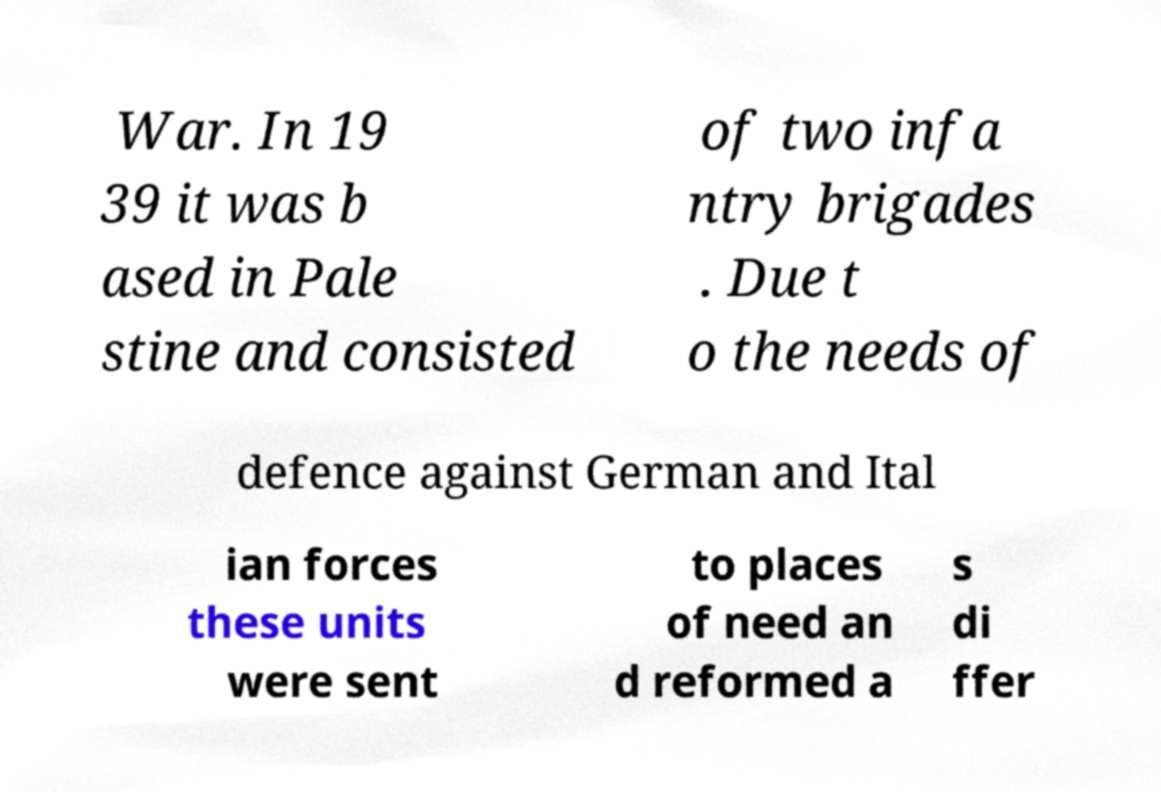There's text embedded in this image that I need extracted. Can you transcribe it verbatim? War. In 19 39 it was b ased in Pale stine and consisted of two infa ntry brigades . Due t o the needs of defence against German and Ital ian forces these units were sent to places of need an d reformed a s di ffer 